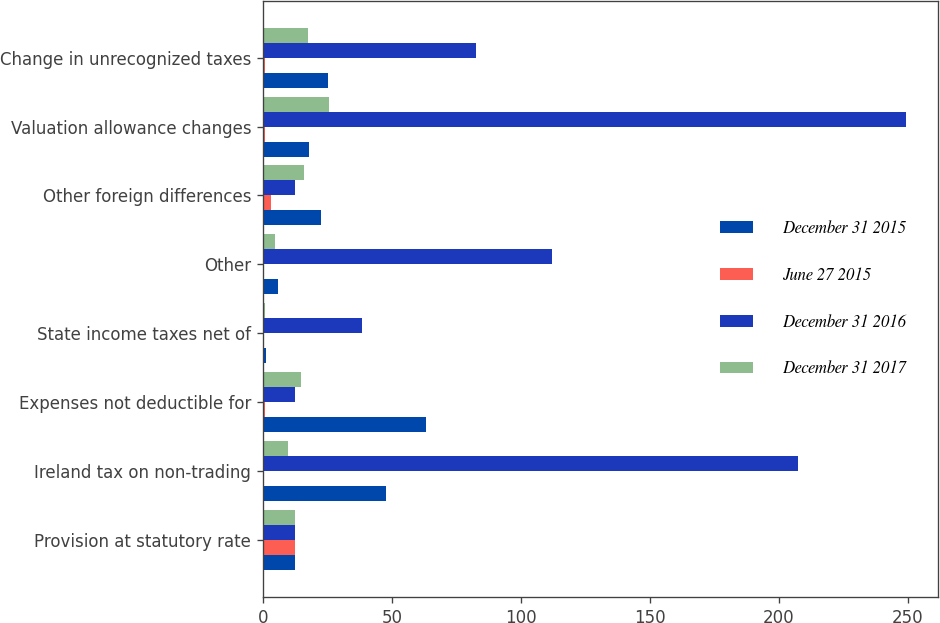Convert chart. <chart><loc_0><loc_0><loc_500><loc_500><stacked_bar_chart><ecel><fcel>Provision at statutory rate<fcel>Ireland tax on non-trading<fcel>Expenses not deductible for<fcel>State income taxes net of<fcel>Other<fcel>Other foreign differences<fcel>Valuation allowance changes<fcel>Change in unrecognized taxes<nl><fcel>December 31 2015<fcel>12.5<fcel>47.7<fcel>63.4<fcel>1.4<fcel>5.8<fcel>22.7<fcel>17.8<fcel>25.3<nl><fcel>June 27 2015<fcel>12.5<fcel>0.4<fcel>0.7<fcel>0.1<fcel>0.4<fcel>3.3<fcel>0.8<fcel>0.8<nl><fcel>December 31 2016<fcel>12.5<fcel>207.4<fcel>12.5<fcel>38.4<fcel>112.3<fcel>12.5<fcel>249.3<fcel>82.7<nl><fcel>December 31 2017<fcel>12.5<fcel>9.9<fcel>14.7<fcel>1<fcel>4.8<fcel>16.1<fcel>25.7<fcel>17.7<nl></chart> 